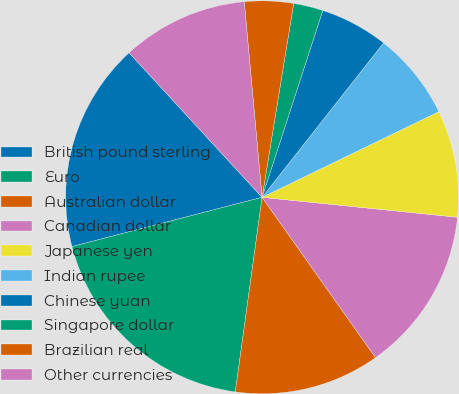Convert chart to OTSL. <chart><loc_0><loc_0><loc_500><loc_500><pie_chart><fcel>British pound sterling<fcel>Euro<fcel>Australian dollar<fcel>Canadian dollar<fcel>Japanese yen<fcel>Indian rupee<fcel>Chinese yuan<fcel>Singapore dollar<fcel>Brazilian real<fcel>Other currencies<nl><fcel>17.2%<fcel>18.79%<fcel>11.98%<fcel>13.58%<fcel>8.8%<fcel>7.21%<fcel>5.61%<fcel>2.43%<fcel>4.02%<fcel>10.39%<nl></chart> 